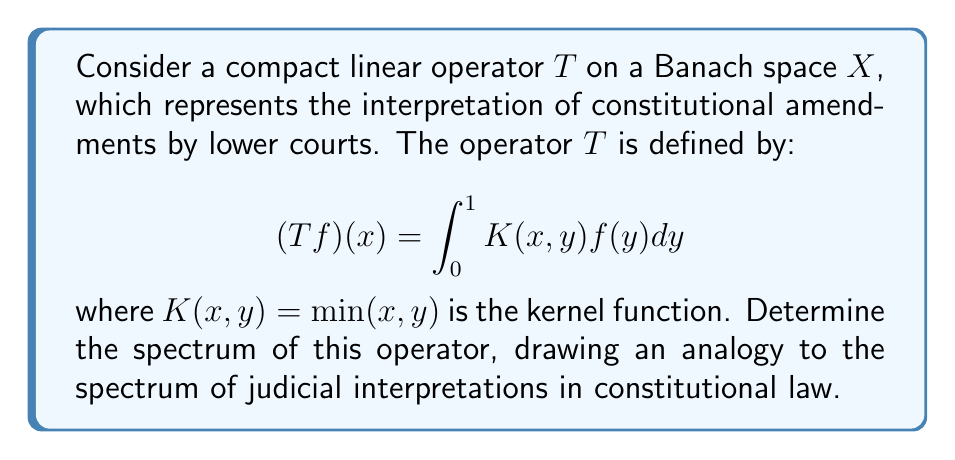Give your solution to this math problem. To determine the spectrum of this compact linear operator, we'll follow these steps:

1) First, recognize that for a compact operator on an infinite-dimensional Banach space, the spectrum consists of 0 and the eigenvalues of the operator.

2) To find the eigenvalues, we need to solve the eigenvalue equation:

   $$(Tf)(x) = \lambda f(x)$$

   Which in our case becomes:

   $$\int_0^1 \min(x,y)f(y)dy = \lambda f(x)$$

3) Differentiate both sides with respect to $x$:

   $$\int_0^x f(y)dy = \lambda f'(x)$$

4) Differentiate again:

   $$f(x) = \lambda f''(x)$$

5) This is a second-order differential equation. The general solution is:

   $$f(x) = A\sin(\frac{x}{\sqrt{\lambda}}) + B\cos(\frac{x}{\sqrt{\lambda}})$$

6) Apply the boundary conditions:
   - $f(0) = 0$ (since the integral at $x=0$ is zero)
   - $f'(1) = 0$ (from step 3, when $x=1$)

7) These conditions lead to:

   $$B = 0$$
   $$\cos(\frac{1}{\sqrt{\lambda}}) = 0$$

8) The second condition is satisfied when:

   $$\frac{1}{\sqrt{\lambda}} = \frac{\pi}{2} + n\pi, \quad n = 0, 1, 2, ...$$

9) Solving for $\lambda$:

   $$\lambda_n = \frac{4}{(2n+1)^2\pi^2}, \quad n = 0, 1, 2, ...$$

Therefore, the spectrum of the operator consists of these eigenvalues and 0.

This spectrum can be analogized to the range of judicial interpretations in constitutional law. The largest eigenvalue ($\lambda_0 = \frac{4}{\pi^2}$) represents the most widely accepted interpretation, while smaller eigenvalues represent less common or more nuanced interpretations. The presence of 0 in the spectrum could represent the possibility of constitutional amendments that have no direct precedent in existing interpretations.
Answer: The spectrum of the operator $T$ is:

$$\{0\} \cup \{\frac{4}{(2n+1)^2\pi^2} : n = 0, 1, 2, ...\}$$ 